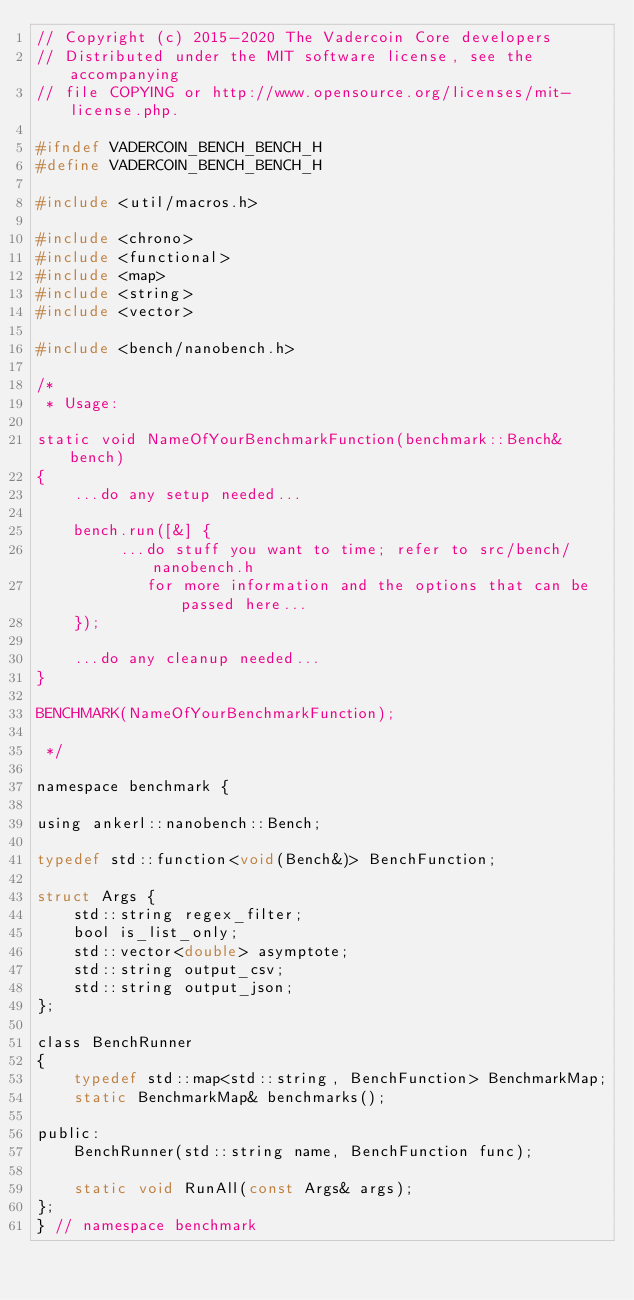<code> <loc_0><loc_0><loc_500><loc_500><_C_>// Copyright (c) 2015-2020 The Vadercoin Core developers
// Distributed under the MIT software license, see the accompanying
// file COPYING or http://www.opensource.org/licenses/mit-license.php.

#ifndef VADERCOIN_BENCH_BENCH_H
#define VADERCOIN_BENCH_BENCH_H

#include <util/macros.h>

#include <chrono>
#include <functional>
#include <map>
#include <string>
#include <vector>

#include <bench/nanobench.h>

/*
 * Usage:

static void NameOfYourBenchmarkFunction(benchmark::Bench& bench)
{
    ...do any setup needed...

    bench.run([&] {
         ...do stuff you want to time; refer to src/bench/nanobench.h
            for more information and the options that can be passed here...
    });

    ...do any cleanup needed...
}

BENCHMARK(NameOfYourBenchmarkFunction);

 */

namespace benchmark {

using ankerl::nanobench::Bench;

typedef std::function<void(Bench&)> BenchFunction;

struct Args {
    std::string regex_filter;
    bool is_list_only;
    std::vector<double> asymptote;
    std::string output_csv;
    std::string output_json;
};

class BenchRunner
{
    typedef std::map<std::string, BenchFunction> BenchmarkMap;
    static BenchmarkMap& benchmarks();

public:
    BenchRunner(std::string name, BenchFunction func);

    static void RunAll(const Args& args);
};
} // namespace benchmark
</code> 